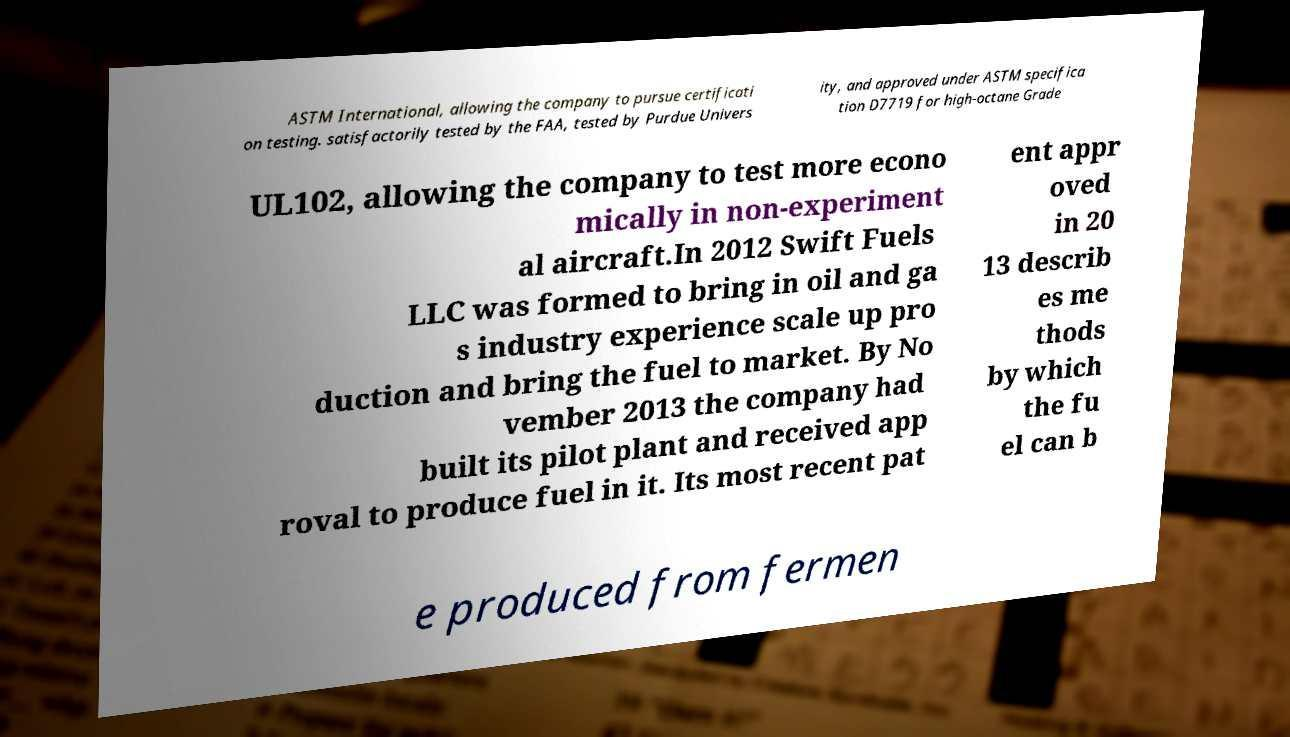What messages or text are displayed in this image? I need them in a readable, typed format. ASTM International, allowing the company to pursue certificati on testing. satisfactorily tested by the FAA, tested by Purdue Univers ity, and approved under ASTM specifica tion D7719 for high-octane Grade UL102, allowing the company to test more econo mically in non-experiment al aircraft.In 2012 Swift Fuels LLC was formed to bring in oil and ga s industry experience scale up pro duction and bring the fuel to market. By No vember 2013 the company had built its pilot plant and received app roval to produce fuel in it. Its most recent pat ent appr oved in 20 13 describ es me thods by which the fu el can b e produced from fermen 